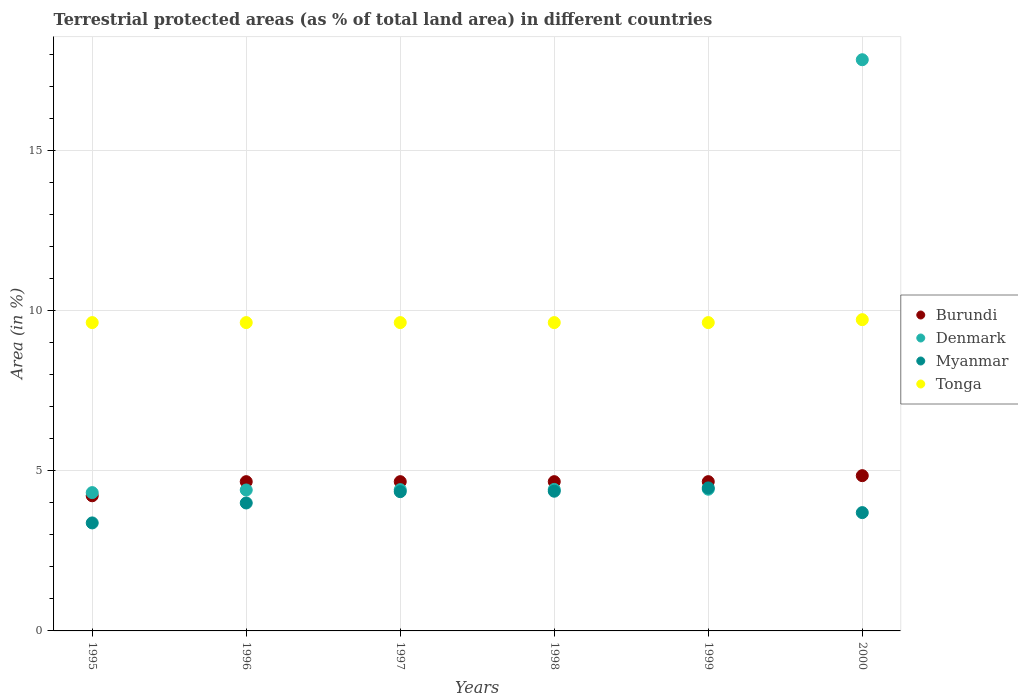Is the number of dotlines equal to the number of legend labels?
Make the answer very short. Yes. What is the percentage of terrestrial protected land in Denmark in 2000?
Provide a short and direct response. 17.84. Across all years, what is the maximum percentage of terrestrial protected land in Burundi?
Make the answer very short. 4.85. Across all years, what is the minimum percentage of terrestrial protected land in Burundi?
Provide a short and direct response. 4.22. What is the total percentage of terrestrial protected land in Tonga in the graph?
Your answer should be very brief. 57.87. What is the difference between the percentage of terrestrial protected land in Myanmar in 1996 and that in 1998?
Provide a succinct answer. -0.37. What is the difference between the percentage of terrestrial protected land in Denmark in 1997 and the percentage of terrestrial protected land in Tonga in 1999?
Ensure brevity in your answer.  -5.22. What is the average percentage of terrestrial protected land in Denmark per year?
Provide a short and direct response. 6.64. In the year 1998, what is the difference between the percentage of terrestrial protected land in Myanmar and percentage of terrestrial protected land in Tonga?
Ensure brevity in your answer.  -5.27. What is the ratio of the percentage of terrestrial protected land in Myanmar in 1997 to that in 2000?
Make the answer very short. 1.18. Is the difference between the percentage of terrestrial protected land in Myanmar in 1998 and 2000 greater than the difference between the percentage of terrestrial protected land in Tonga in 1998 and 2000?
Give a very brief answer. Yes. What is the difference between the highest and the second highest percentage of terrestrial protected land in Denmark?
Your answer should be very brief. 13.41. What is the difference between the highest and the lowest percentage of terrestrial protected land in Denmark?
Offer a very short reply. 13.52. In how many years, is the percentage of terrestrial protected land in Tonga greater than the average percentage of terrestrial protected land in Tonga taken over all years?
Give a very brief answer. 1. Is the sum of the percentage of terrestrial protected land in Denmark in 1996 and 1999 greater than the maximum percentage of terrestrial protected land in Myanmar across all years?
Your answer should be very brief. Yes. Is it the case that in every year, the sum of the percentage of terrestrial protected land in Denmark and percentage of terrestrial protected land in Burundi  is greater than the percentage of terrestrial protected land in Myanmar?
Keep it short and to the point. Yes. Is the percentage of terrestrial protected land in Tonga strictly greater than the percentage of terrestrial protected land in Burundi over the years?
Your answer should be compact. Yes. Does the graph contain grids?
Your answer should be compact. Yes. Where does the legend appear in the graph?
Ensure brevity in your answer.  Center right. How many legend labels are there?
Give a very brief answer. 4. How are the legend labels stacked?
Your answer should be very brief. Vertical. What is the title of the graph?
Your answer should be compact. Terrestrial protected areas (as % of total land area) in different countries. Does "Mozambique" appear as one of the legend labels in the graph?
Make the answer very short. No. What is the label or title of the Y-axis?
Give a very brief answer. Area (in %). What is the Area (in %) of Burundi in 1995?
Keep it short and to the point. 4.22. What is the Area (in %) in Denmark in 1995?
Keep it short and to the point. 4.32. What is the Area (in %) in Myanmar in 1995?
Give a very brief answer. 3.37. What is the Area (in %) of Tonga in 1995?
Offer a terse response. 9.63. What is the Area (in %) of Burundi in 1996?
Keep it short and to the point. 4.66. What is the Area (in %) of Denmark in 1996?
Give a very brief answer. 4.4. What is the Area (in %) in Myanmar in 1996?
Your answer should be very brief. 4. What is the Area (in %) in Tonga in 1996?
Keep it short and to the point. 9.63. What is the Area (in %) in Burundi in 1997?
Give a very brief answer. 4.66. What is the Area (in %) of Denmark in 1997?
Your response must be concise. 4.41. What is the Area (in %) of Myanmar in 1997?
Offer a very short reply. 4.35. What is the Area (in %) of Tonga in 1997?
Offer a very short reply. 9.63. What is the Area (in %) of Burundi in 1998?
Your answer should be very brief. 4.66. What is the Area (in %) in Denmark in 1998?
Provide a short and direct response. 4.42. What is the Area (in %) of Myanmar in 1998?
Ensure brevity in your answer.  4.36. What is the Area (in %) of Tonga in 1998?
Make the answer very short. 9.63. What is the Area (in %) in Burundi in 1999?
Keep it short and to the point. 4.66. What is the Area (in %) in Denmark in 1999?
Give a very brief answer. 4.43. What is the Area (in %) of Myanmar in 1999?
Offer a terse response. 4.47. What is the Area (in %) in Tonga in 1999?
Provide a short and direct response. 9.63. What is the Area (in %) of Burundi in 2000?
Offer a terse response. 4.85. What is the Area (in %) of Denmark in 2000?
Make the answer very short. 17.84. What is the Area (in %) of Myanmar in 2000?
Your response must be concise. 3.7. What is the Area (in %) in Tonga in 2000?
Your answer should be very brief. 9.72. Across all years, what is the maximum Area (in %) of Burundi?
Give a very brief answer. 4.85. Across all years, what is the maximum Area (in %) of Denmark?
Your answer should be very brief. 17.84. Across all years, what is the maximum Area (in %) of Myanmar?
Your answer should be very brief. 4.47. Across all years, what is the maximum Area (in %) of Tonga?
Ensure brevity in your answer.  9.72. Across all years, what is the minimum Area (in %) in Burundi?
Ensure brevity in your answer.  4.22. Across all years, what is the minimum Area (in %) of Denmark?
Make the answer very short. 4.32. Across all years, what is the minimum Area (in %) of Myanmar?
Give a very brief answer. 3.37. Across all years, what is the minimum Area (in %) in Tonga?
Keep it short and to the point. 9.63. What is the total Area (in %) in Burundi in the graph?
Your answer should be very brief. 27.72. What is the total Area (in %) of Denmark in the graph?
Give a very brief answer. 39.82. What is the total Area (in %) of Myanmar in the graph?
Provide a succinct answer. 24.25. What is the total Area (in %) of Tonga in the graph?
Your answer should be very brief. 57.87. What is the difference between the Area (in %) in Burundi in 1995 and that in 1996?
Ensure brevity in your answer.  -0.44. What is the difference between the Area (in %) in Denmark in 1995 and that in 1996?
Provide a short and direct response. -0.08. What is the difference between the Area (in %) in Myanmar in 1995 and that in 1996?
Provide a short and direct response. -0.62. What is the difference between the Area (in %) in Burundi in 1995 and that in 1997?
Ensure brevity in your answer.  -0.44. What is the difference between the Area (in %) of Denmark in 1995 and that in 1997?
Ensure brevity in your answer.  -0.09. What is the difference between the Area (in %) in Myanmar in 1995 and that in 1997?
Ensure brevity in your answer.  -0.98. What is the difference between the Area (in %) of Burundi in 1995 and that in 1998?
Offer a very short reply. -0.44. What is the difference between the Area (in %) in Myanmar in 1995 and that in 1998?
Provide a short and direct response. -0.99. What is the difference between the Area (in %) of Tonga in 1995 and that in 1998?
Provide a short and direct response. 0. What is the difference between the Area (in %) of Burundi in 1995 and that in 1999?
Your answer should be compact. -0.44. What is the difference between the Area (in %) in Denmark in 1995 and that in 1999?
Your response must be concise. -0.11. What is the difference between the Area (in %) of Myanmar in 1995 and that in 1999?
Your answer should be very brief. -1.09. What is the difference between the Area (in %) of Burundi in 1995 and that in 2000?
Offer a terse response. -0.63. What is the difference between the Area (in %) in Denmark in 1995 and that in 2000?
Offer a very short reply. -13.52. What is the difference between the Area (in %) of Myanmar in 1995 and that in 2000?
Your answer should be very brief. -0.32. What is the difference between the Area (in %) in Tonga in 1995 and that in 2000?
Your answer should be very brief. -0.09. What is the difference between the Area (in %) of Denmark in 1996 and that in 1997?
Ensure brevity in your answer.  -0.01. What is the difference between the Area (in %) in Myanmar in 1996 and that in 1997?
Provide a short and direct response. -0.35. What is the difference between the Area (in %) of Tonga in 1996 and that in 1997?
Your response must be concise. 0. What is the difference between the Area (in %) of Denmark in 1996 and that in 1998?
Keep it short and to the point. -0.02. What is the difference between the Area (in %) in Myanmar in 1996 and that in 1998?
Ensure brevity in your answer.  -0.37. What is the difference between the Area (in %) in Tonga in 1996 and that in 1998?
Provide a short and direct response. 0. What is the difference between the Area (in %) of Denmark in 1996 and that in 1999?
Ensure brevity in your answer.  -0.02. What is the difference between the Area (in %) of Myanmar in 1996 and that in 1999?
Offer a very short reply. -0.47. What is the difference between the Area (in %) in Tonga in 1996 and that in 1999?
Your response must be concise. 0. What is the difference between the Area (in %) of Burundi in 1996 and that in 2000?
Your response must be concise. -0.19. What is the difference between the Area (in %) in Denmark in 1996 and that in 2000?
Give a very brief answer. -13.44. What is the difference between the Area (in %) of Myanmar in 1996 and that in 2000?
Keep it short and to the point. 0.3. What is the difference between the Area (in %) of Tonga in 1996 and that in 2000?
Provide a short and direct response. -0.09. What is the difference between the Area (in %) in Burundi in 1997 and that in 1998?
Offer a very short reply. 0. What is the difference between the Area (in %) in Denmark in 1997 and that in 1998?
Keep it short and to the point. -0.01. What is the difference between the Area (in %) of Myanmar in 1997 and that in 1998?
Provide a succinct answer. -0.01. What is the difference between the Area (in %) of Denmark in 1997 and that in 1999?
Your answer should be compact. -0.01. What is the difference between the Area (in %) of Myanmar in 1997 and that in 1999?
Provide a short and direct response. -0.12. What is the difference between the Area (in %) in Burundi in 1997 and that in 2000?
Make the answer very short. -0.19. What is the difference between the Area (in %) in Denmark in 1997 and that in 2000?
Provide a succinct answer. -13.43. What is the difference between the Area (in %) in Myanmar in 1997 and that in 2000?
Offer a terse response. 0.65. What is the difference between the Area (in %) of Tonga in 1997 and that in 2000?
Provide a short and direct response. -0.09. What is the difference between the Area (in %) in Burundi in 1998 and that in 1999?
Your answer should be compact. 0. What is the difference between the Area (in %) of Denmark in 1998 and that in 1999?
Your answer should be compact. -0.01. What is the difference between the Area (in %) of Myanmar in 1998 and that in 1999?
Keep it short and to the point. -0.1. What is the difference between the Area (in %) of Burundi in 1998 and that in 2000?
Your answer should be very brief. -0.19. What is the difference between the Area (in %) of Denmark in 1998 and that in 2000?
Make the answer very short. -13.42. What is the difference between the Area (in %) of Myanmar in 1998 and that in 2000?
Offer a terse response. 0.67. What is the difference between the Area (in %) of Tonga in 1998 and that in 2000?
Your response must be concise. -0.09. What is the difference between the Area (in %) in Burundi in 1999 and that in 2000?
Your answer should be compact. -0.19. What is the difference between the Area (in %) in Denmark in 1999 and that in 2000?
Offer a terse response. -13.41. What is the difference between the Area (in %) of Myanmar in 1999 and that in 2000?
Offer a terse response. 0.77. What is the difference between the Area (in %) of Tonga in 1999 and that in 2000?
Your answer should be very brief. -0.09. What is the difference between the Area (in %) in Burundi in 1995 and the Area (in %) in Denmark in 1996?
Provide a short and direct response. -0.18. What is the difference between the Area (in %) of Burundi in 1995 and the Area (in %) of Myanmar in 1996?
Your response must be concise. 0.23. What is the difference between the Area (in %) in Burundi in 1995 and the Area (in %) in Tonga in 1996?
Provide a succinct answer. -5.41. What is the difference between the Area (in %) in Denmark in 1995 and the Area (in %) in Myanmar in 1996?
Provide a short and direct response. 0.32. What is the difference between the Area (in %) in Denmark in 1995 and the Area (in %) in Tonga in 1996?
Make the answer very short. -5.31. What is the difference between the Area (in %) of Myanmar in 1995 and the Area (in %) of Tonga in 1996?
Provide a short and direct response. -6.26. What is the difference between the Area (in %) of Burundi in 1995 and the Area (in %) of Denmark in 1997?
Provide a short and direct response. -0.19. What is the difference between the Area (in %) of Burundi in 1995 and the Area (in %) of Myanmar in 1997?
Offer a very short reply. -0.13. What is the difference between the Area (in %) of Burundi in 1995 and the Area (in %) of Tonga in 1997?
Your answer should be very brief. -5.41. What is the difference between the Area (in %) in Denmark in 1995 and the Area (in %) in Myanmar in 1997?
Offer a terse response. -0.03. What is the difference between the Area (in %) in Denmark in 1995 and the Area (in %) in Tonga in 1997?
Make the answer very short. -5.31. What is the difference between the Area (in %) in Myanmar in 1995 and the Area (in %) in Tonga in 1997?
Your answer should be compact. -6.26. What is the difference between the Area (in %) in Burundi in 1995 and the Area (in %) in Denmark in 1998?
Offer a terse response. -0.2. What is the difference between the Area (in %) in Burundi in 1995 and the Area (in %) in Myanmar in 1998?
Provide a short and direct response. -0.14. What is the difference between the Area (in %) in Burundi in 1995 and the Area (in %) in Tonga in 1998?
Make the answer very short. -5.41. What is the difference between the Area (in %) of Denmark in 1995 and the Area (in %) of Myanmar in 1998?
Make the answer very short. -0.04. What is the difference between the Area (in %) of Denmark in 1995 and the Area (in %) of Tonga in 1998?
Offer a terse response. -5.31. What is the difference between the Area (in %) in Myanmar in 1995 and the Area (in %) in Tonga in 1998?
Keep it short and to the point. -6.26. What is the difference between the Area (in %) of Burundi in 1995 and the Area (in %) of Denmark in 1999?
Your response must be concise. -0.2. What is the difference between the Area (in %) of Burundi in 1995 and the Area (in %) of Myanmar in 1999?
Offer a terse response. -0.25. What is the difference between the Area (in %) of Burundi in 1995 and the Area (in %) of Tonga in 1999?
Your answer should be compact. -5.41. What is the difference between the Area (in %) in Denmark in 1995 and the Area (in %) in Myanmar in 1999?
Ensure brevity in your answer.  -0.15. What is the difference between the Area (in %) in Denmark in 1995 and the Area (in %) in Tonga in 1999?
Give a very brief answer. -5.31. What is the difference between the Area (in %) of Myanmar in 1995 and the Area (in %) of Tonga in 1999?
Give a very brief answer. -6.26. What is the difference between the Area (in %) of Burundi in 1995 and the Area (in %) of Denmark in 2000?
Offer a terse response. -13.62. What is the difference between the Area (in %) of Burundi in 1995 and the Area (in %) of Myanmar in 2000?
Give a very brief answer. 0.53. What is the difference between the Area (in %) in Burundi in 1995 and the Area (in %) in Tonga in 2000?
Offer a terse response. -5.5. What is the difference between the Area (in %) of Denmark in 1995 and the Area (in %) of Myanmar in 2000?
Ensure brevity in your answer.  0.62. What is the difference between the Area (in %) in Denmark in 1995 and the Area (in %) in Tonga in 2000?
Ensure brevity in your answer.  -5.4. What is the difference between the Area (in %) of Myanmar in 1995 and the Area (in %) of Tonga in 2000?
Ensure brevity in your answer.  -6.35. What is the difference between the Area (in %) of Burundi in 1996 and the Area (in %) of Denmark in 1997?
Provide a succinct answer. 0.25. What is the difference between the Area (in %) of Burundi in 1996 and the Area (in %) of Myanmar in 1997?
Make the answer very short. 0.31. What is the difference between the Area (in %) in Burundi in 1996 and the Area (in %) in Tonga in 1997?
Your answer should be very brief. -4.97. What is the difference between the Area (in %) in Denmark in 1996 and the Area (in %) in Myanmar in 1997?
Keep it short and to the point. 0.05. What is the difference between the Area (in %) in Denmark in 1996 and the Area (in %) in Tonga in 1997?
Your response must be concise. -5.23. What is the difference between the Area (in %) of Myanmar in 1996 and the Area (in %) of Tonga in 1997?
Give a very brief answer. -5.63. What is the difference between the Area (in %) of Burundi in 1996 and the Area (in %) of Denmark in 1998?
Offer a terse response. 0.24. What is the difference between the Area (in %) in Burundi in 1996 and the Area (in %) in Myanmar in 1998?
Provide a succinct answer. 0.3. What is the difference between the Area (in %) of Burundi in 1996 and the Area (in %) of Tonga in 1998?
Make the answer very short. -4.97. What is the difference between the Area (in %) of Denmark in 1996 and the Area (in %) of Myanmar in 1998?
Ensure brevity in your answer.  0.04. What is the difference between the Area (in %) in Denmark in 1996 and the Area (in %) in Tonga in 1998?
Your response must be concise. -5.23. What is the difference between the Area (in %) of Myanmar in 1996 and the Area (in %) of Tonga in 1998?
Make the answer very short. -5.63. What is the difference between the Area (in %) of Burundi in 1996 and the Area (in %) of Denmark in 1999?
Keep it short and to the point. 0.24. What is the difference between the Area (in %) of Burundi in 1996 and the Area (in %) of Myanmar in 1999?
Keep it short and to the point. 0.19. What is the difference between the Area (in %) of Burundi in 1996 and the Area (in %) of Tonga in 1999?
Ensure brevity in your answer.  -4.97. What is the difference between the Area (in %) of Denmark in 1996 and the Area (in %) of Myanmar in 1999?
Make the answer very short. -0.07. What is the difference between the Area (in %) in Denmark in 1996 and the Area (in %) in Tonga in 1999?
Your answer should be very brief. -5.23. What is the difference between the Area (in %) in Myanmar in 1996 and the Area (in %) in Tonga in 1999?
Offer a terse response. -5.63. What is the difference between the Area (in %) of Burundi in 1996 and the Area (in %) of Denmark in 2000?
Offer a very short reply. -13.18. What is the difference between the Area (in %) of Burundi in 1996 and the Area (in %) of Myanmar in 2000?
Make the answer very short. 0.97. What is the difference between the Area (in %) in Burundi in 1996 and the Area (in %) in Tonga in 2000?
Offer a terse response. -5.06. What is the difference between the Area (in %) in Denmark in 1996 and the Area (in %) in Myanmar in 2000?
Provide a succinct answer. 0.71. What is the difference between the Area (in %) of Denmark in 1996 and the Area (in %) of Tonga in 2000?
Provide a short and direct response. -5.32. What is the difference between the Area (in %) of Myanmar in 1996 and the Area (in %) of Tonga in 2000?
Provide a short and direct response. -5.73. What is the difference between the Area (in %) in Burundi in 1997 and the Area (in %) in Denmark in 1998?
Your answer should be compact. 0.24. What is the difference between the Area (in %) in Burundi in 1997 and the Area (in %) in Myanmar in 1998?
Make the answer very short. 0.3. What is the difference between the Area (in %) of Burundi in 1997 and the Area (in %) of Tonga in 1998?
Offer a terse response. -4.97. What is the difference between the Area (in %) in Denmark in 1997 and the Area (in %) in Myanmar in 1998?
Make the answer very short. 0.05. What is the difference between the Area (in %) of Denmark in 1997 and the Area (in %) of Tonga in 1998?
Make the answer very short. -5.22. What is the difference between the Area (in %) of Myanmar in 1997 and the Area (in %) of Tonga in 1998?
Make the answer very short. -5.28. What is the difference between the Area (in %) of Burundi in 1997 and the Area (in %) of Denmark in 1999?
Your answer should be very brief. 0.24. What is the difference between the Area (in %) of Burundi in 1997 and the Area (in %) of Myanmar in 1999?
Your answer should be very brief. 0.19. What is the difference between the Area (in %) of Burundi in 1997 and the Area (in %) of Tonga in 1999?
Offer a terse response. -4.97. What is the difference between the Area (in %) of Denmark in 1997 and the Area (in %) of Myanmar in 1999?
Provide a succinct answer. -0.05. What is the difference between the Area (in %) of Denmark in 1997 and the Area (in %) of Tonga in 1999?
Make the answer very short. -5.22. What is the difference between the Area (in %) of Myanmar in 1997 and the Area (in %) of Tonga in 1999?
Keep it short and to the point. -5.28. What is the difference between the Area (in %) in Burundi in 1997 and the Area (in %) in Denmark in 2000?
Provide a succinct answer. -13.18. What is the difference between the Area (in %) in Burundi in 1997 and the Area (in %) in Myanmar in 2000?
Provide a succinct answer. 0.97. What is the difference between the Area (in %) in Burundi in 1997 and the Area (in %) in Tonga in 2000?
Provide a short and direct response. -5.06. What is the difference between the Area (in %) in Denmark in 1997 and the Area (in %) in Myanmar in 2000?
Provide a succinct answer. 0.72. What is the difference between the Area (in %) in Denmark in 1997 and the Area (in %) in Tonga in 2000?
Offer a very short reply. -5.31. What is the difference between the Area (in %) in Myanmar in 1997 and the Area (in %) in Tonga in 2000?
Your response must be concise. -5.37. What is the difference between the Area (in %) of Burundi in 1998 and the Area (in %) of Denmark in 1999?
Provide a short and direct response. 0.24. What is the difference between the Area (in %) in Burundi in 1998 and the Area (in %) in Myanmar in 1999?
Provide a succinct answer. 0.19. What is the difference between the Area (in %) of Burundi in 1998 and the Area (in %) of Tonga in 1999?
Your answer should be compact. -4.97. What is the difference between the Area (in %) of Denmark in 1998 and the Area (in %) of Myanmar in 1999?
Offer a very short reply. -0.05. What is the difference between the Area (in %) in Denmark in 1998 and the Area (in %) in Tonga in 1999?
Make the answer very short. -5.21. What is the difference between the Area (in %) of Myanmar in 1998 and the Area (in %) of Tonga in 1999?
Give a very brief answer. -5.27. What is the difference between the Area (in %) in Burundi in 1998 and the Area (in %) in Denmark in 2000?
Your answer should be very brief. -13.18. What is the difference between the Area (in %) of Burundi in 1998 and the Area (in %) of Tonga in 2000?
Offer a very short reply. -5.06. What is the difference between the Area (in %) in Denmark in 1998 and the Area (in %) in Myanmar in 2000?
Provide a short and direct response. 0.72. What is the difference between the Area (in %) in Denmark in 1998 and the Area (in %) in Tonga in 2000?
Your answer should be compact. -5.3. What is the difference between the Area (in %) in Myanmar in 1998 and the Area (in %) in Tonga in 2000?
Keep it short and to the point. -5.36. What is the difference between the Area (in %) of Burundi in 1999 and the Area (in %) of Denmark in 2000?
Provide a succinct answer. -13.18. What is the difference between the Area (in %) of Burundi in 1999 and the Area (in %) of Tonga in 2000?
Your answer should be very brief. -5.06. What is the difference between the Area (in %) of Denmark in 1999 and the Area (in %) of Myanmar in 2000?
Keep it short and to the point. 0.73. What is the difference between the Area (in %) of Denmark in 1999 and the Area (in %) of Tonga in 2000?
Provide a short and direct response. -5.3. What is the difference between the Area (in %) in Myanmar in 1999 and the Area (in %) in Tonga in 2000?
Your response must be concise. -5.25. What is the average Area (in %) of Burundi per year?
Your response must be concise. 4.62. What is the average Area (in %) in Denmark per year?
Your answer should be very brief. 6.64. What is the average Area (in %) in Myanmar per year?
Give a very brief answer. 4.04. What is the average Area (in %) in Tonga per year?
Provide a succinct answer. 9.65. In the year 1995, what is the difference between the Area (in %) in Burundi and Area (in %) in Denmark?
Keep it short and to the point. -0.1. In the year 1995, what is the difference between the Area (in %) in Burundi and Area (in %) in Myanmar?
Provide a succinct answer. 0.85. In the year 1995, what is the difference between the Area (in %) in Burundi and Area (in %) in Tonga?
Ensure brevity in your answer.  -5.41. In the year 1995, what is the difference between the Area (in %) in Denmark and Area (in %) in Myanmar?
Provide a succinct answer. 0.95. In the year 1995, what is the difference between the Area (in %) of Denmark and Area (in %) of Tonga?
Offer a terse response. -5.31. In the year 1995, what is the difference between the Area (in %) in Myanmar and Area (in %) in Tonga?
Offer a terse response. -6.26. In the year 1996, what is the difference between the Area (in %) in Burundi and Area (in %) in Denmark?
Your answer should be compact. 0.26. In the year 1996, what is the difference between the Area (in %) in Burundi and Area (in %) in Myanmar?
Offer a terse response. 0.67. In the year 1996, what is the difference between the Area (in %) in Burundi and Area (in %) in Tonga?
Give a very brief answer. -4.97. In the year 1996, what is the difference between the Area (in %) of Denmark and Area (in %) of Myanmar?
Give a very brief answer. 0.41. In the year 1996, what is the difference between the Area (in %) of Denmark and Area (in %) of Tonga?
Offer a terse response. -5.23. In the year 1996, what is the difference between the Area (in %) in Myanmar and Area (in %) in Tonga?
Ensure brevity in your answer.  -5.63. In the year 1997, what is the difference between the Area (in %) of Burundi and Area (in %) of Denmark?
Provide a succinct answer. 0.25. In the year 1997, what is the difference between the Area (in %) in Burundi and Area (in %) in Myanmar?
Your response must be concise. 0.31. In the year 1997, what is the difference between the Area (in %) in Burundi and Area (in %) in Tonga?
Offer a terse response. -4.97. In the year 1997, what is the difference between the Area (in %) of Denmark and Area (in %) of Myanmar?
Provide a short and direct response. 0.06. In the year 1997, what is the difference between the Area (in %) of Denmark and Area (in %) of Tonga?
Give a very brief answer. -5.22. In the year 1997, what is the difference between the Area (in %) of Myanmar and Area (in %) of Tonga?
Provide a short and direct response. -5.28. In the year 1998, what is the difference between the Area (in %) of Burundi and Area (in %) of Denmark?
Make the answer very short. 0.24. In the year 1998, what is the difference between the Area (in %) in Burundi and Area (in %) in Myanmar?
Your answer should be compact. 0.3. In the year 1998, what is the difference between the Area (in %) of Burundi and Area (in %) of Tonga?
Provide a short and direct response. -4.97. In the year 1998, what is the difference between the Area (in %) in Denmark and Area (in %) in Myanmar?
Keep it short and to the point. 0.06. In the year 1998, what is the difference between the Area (in %) in Denmark and Area (in %) in Tonga?
Keep it short and to the point. -5.21. In the year 1998, what is the difference between the Area (in %) of Myanmar and Area (in %) of Tonga?
Your answer should be compact. -5.27. In the year 1999, what is the difference between the Area (in %) in Burundi and Area (in %) in Denmark?
Keep it short and to the point. 0.24. In the year 1999, what is the difference between the Area (in %) in Burundi and Area (in %) in Myanmar?
Ensure brevity in your answer.  0.19. In the year 1999, what is the difference between the Area (in %) of Burundi and Area (in %) of Tonga?
Offer a very short reply. -4.97. In the year 1999, what is the difference between the Area (in %) in Denmark and Area (in %) in Myanmar?
Keep it short and to the point. -0.04. In the year 1999, what is the difference between the Area (in %) in Denmark and Area (in %) in Tonga?
Your answer should be very brief. -5.2. In the year 1999, what is the difference between the Area (in %) of Myanmar and Area (in %) of Tonga?
Offer a very short reply. -5.16. In the year 2000, what is the difference between the Area (in %) of Burundi and Area (in %) of Denmark?
Provide a succinct answer. -12.99. In the year 2000, what is the difference between the Area (in %) in Burundi and Area (in %) in Myanmar?
Provide a succinct answer. 1.15. In the year 2000, what is the difference between the Area (in %) in Burundi and Area (in %) in Tonga?
Provide a succinct answer. -4.87. In the year 2000, what is the difference between the Area (in %) of Denmark and Area (in %) of Myanmar?
Make the answer very short. 14.15. In the year 2000, what is the difference between the Area (in %) in Denmark and Area (in %) in Tonga?
Offer a very short reply. 8.12. In the year 2000, what is the difference between the Area (in %) of Myanmar and Area (in %) of Tonga?
Make the answer very short. -6.03. What is the ratio of the Area (in %) of Burundi in 1995 to that in 1996?
Make the answer very short. 0.91. What is the ratio of the Area (in %) in Denmark in 1995 to that in 1996?
Provide a succinct answer. 0.98. What is the ratio of the Area (in %) of Myanmar in 1995 to that in 1996?
Your response must be concise. 0.84. What is the ratio of the Area (in %) in Tonga in 1995 to that in 1996?
Provide a short and direct response. 1. What is the ratio of the Area (in %) in Burundi in 1995 to that in 1997?
Your answer should be compact. 0.91. What is the ratio of the Area (in %) in Denmark in 1995 to that in 1997?
Your answer should be very brief. 0.98. What is the ratio of the Area (in %) of Myanmar in 1995 to that in 1997?
Provide a short and direct response. 0.78. What is the ratio of the Area (in %) of Burundi in 1995 to that in 1998?
Provide a short and direct response. 0.91. What is the ratio of the Area (in %) in Denmark in 1995 to that in 1998?
Make the answer very short. 0.98. What is the ratio of the Area (in %) in Myanmar in 1995 to that in 1998?
Your answer should be compact. 0.77. What is the ratio of the Area (in %) of Burundi in 1995 to that in 1999?
Your answer should be compact. 0.91. What is the ratio of the Area (in %) of Denmark in 1995 to that in 1999?
Your answer should be compact. 0.98. What is the ratio of the Area (in %) of Myanmar in 1995 to that in 1999?
Provide a short and direct response. 0.76. What is the ratio of the Area (in %) in Burundi in 1995 to that in 2000?
Offer a very short reply. 0.87. What is the ratio of the Area (in %) of Denmark in 1995 to that in 2000?
Your answer should be very brief. 0.24. What is the ratio of the Area (in %) in Myanmar in 1995 to that in 2000?
Your answer should be very brief. 0.91. What is the ratio of the Area (in %) in Tonga in 1995 to that in 2000?
Give a very brief answer. 0.99. What is the ratio of the Area (in %) in Myanmar in 1996 to that in 1997?
Give a very brief answer. 0.92. What is the ratio of the Area (in %) of Burundi in 1996 to that in 1998?
Offer a terse response. 1. What is the ratio of the Area (in %) of Myanmar in 1996 to that in 1998?
Make the answer very short. 0.92. What is the ratio of the Area (in %) in Tonga in 1996 to that in 1998?
Keep it short and to the point. 1. What is the ratio of the Area (in %) in Burundi in 1996 to that in 1999?
Give a very brief answer. 1. What is the ratio of the Area (in %) of Myanmar in 1996 to that in 1999?
Your response must be concise. 0.89. What is the ratio of the Area (in %) of Burundi in 1996 to that in 2000?
Your answer should be very brief. 0.96. What is the ratio of the Area (in %) of Denmark in 1996 to that in 2000?
Make the answer very short. 0.25. What is the ratio of the Area (in %) of Myanmar in 1996 to that in 2000?
Your answer should be very brief. 1.08. What is the ratio of the Area (in %) of Tonga in 1996 to that in 2000?
Offer a very short reply. 0.99. What is the ratio of the Area (in %) of Burundi in 1997 to that in 1998?
Offer a very short reply. 1. What is the ratio of the Area (in %) of Burundi in 1997 to that in 1999?
Your response must be concise. 1. What is the ratio of the Area (in %) in Denmark in 1997 to that in 1999?
Offer a very short reply. 1. What is the ratio of the Area (in %) in Myanmar in 1997 to that in 1999?
Ensure brevity in your answer.  0.97. What is the ratio of the Area (in %) in Tonga in 1997 to that in 1999?
Ensure brevity in your answer.  1. What is the ratio of the Area (in %) of Burundi in 1997 to that in 2000?
Your response must be concise. 0.96. What is the ratio of the Area (in %) in Denmark in 1997 to that in 2000?
Your answer should be compact. 0.25. What is the ratio of the Area (in %) of Myanmar in 1997 to that in 2000?
Offer a very short reply. 1.18. What is the ratio of the Area (in %) of Tonga in 1997 to that in 2000?
Offer a very short reply. 0.99. What is the ratio of the Area (in %) in Denmark in 1998 to that in 1999?
Give a very brief answer. 1. What is the ratio of the Area (in %) of Myanmar in 1998 to that in 1999?
Offer a very short reply. 0.98. What is the ratio of the Area (in %) in Tonga in 1998 to that in 1999?
Offer a terse response. 1. What is the ratio of the Area (in %) of Burundi in 1998 to that in 2000?
Offer a terse response. 0.96. What is the ratio of the Area (in %) in Denmark in 1998 to that in 2000?
Offer a very short reply. 0.25. What is the ratio of the Area (in %) of Myanmar in 1998 to that in 2000?
Your answer should be very brief. 1.18. What is the ratio of the Area (in %) in Tonga in 1998 to that in 2000?
Ensure brevity in your answer.  0.99. What is the ratio of the Area (in %) in Burundi in 1999 to that in 2000?
Keep it short and to the point. 0.96. What is the ratio of the Area (in %) of Denmark in 1999 to that in 2000?
Keep it short and to the point. 0.25. What is the ratio of the Area (in %) in Myanmar in 1999 to that in 2000?
Give a very brief answer. 1.21. What is the ratio of the Area (in %) in Tonga in 1999 to that in 2000?
Your response must be concise. 0.99. What is the difference between the highest and the second highest Area (in %) of Burundi?
Your response must be concise. 0.19. What is the difference between the highest and the second highest Area (in %) of Denmark?
Offer a terse response. 13.41. What is the difference between the highest and the second highest Area (in %) of Myanmar?
Your answer should be very brief. 0.1. What is the difference between the highest and the second highest Area (in %) of Tonga?
Your answer should be compact. 0.09. What is the difference between the highest and the lowest Area (in %) of Burundi?
Keep it short and to the point. 0.63. What is the difference between the highest and the lowest Area (in %) of Denmark?
Provide a short and direct response. 13.52. What is the difference between the highest and the lowest Area (in %) in Myanmar?
Make the answer very short. 1.09. What is the difference between the highest and the lowest Area (in %) of Tonga?
Give a very brief answer. 0.09. 